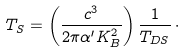Convert formula to latex. <formula><loc_0><loc_0><loc_500><loc_500>T _ { S } = \left ( \frac { c ^ { 3 } } { 2 \pi \alpha ^ { \prime } K _ { B } ^ { 2 } } \right ) \frac { 1 } { T _ { D S } } \, \cdot</formula> 